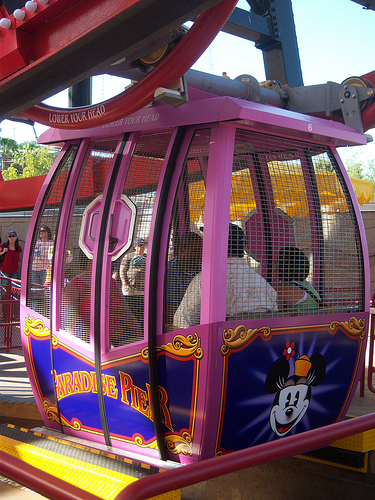<image>
Can you confirm if the women is to the left of the man? No. The women is not to the left of the man. From this viewpoint, they have a different horizontal relationship. 